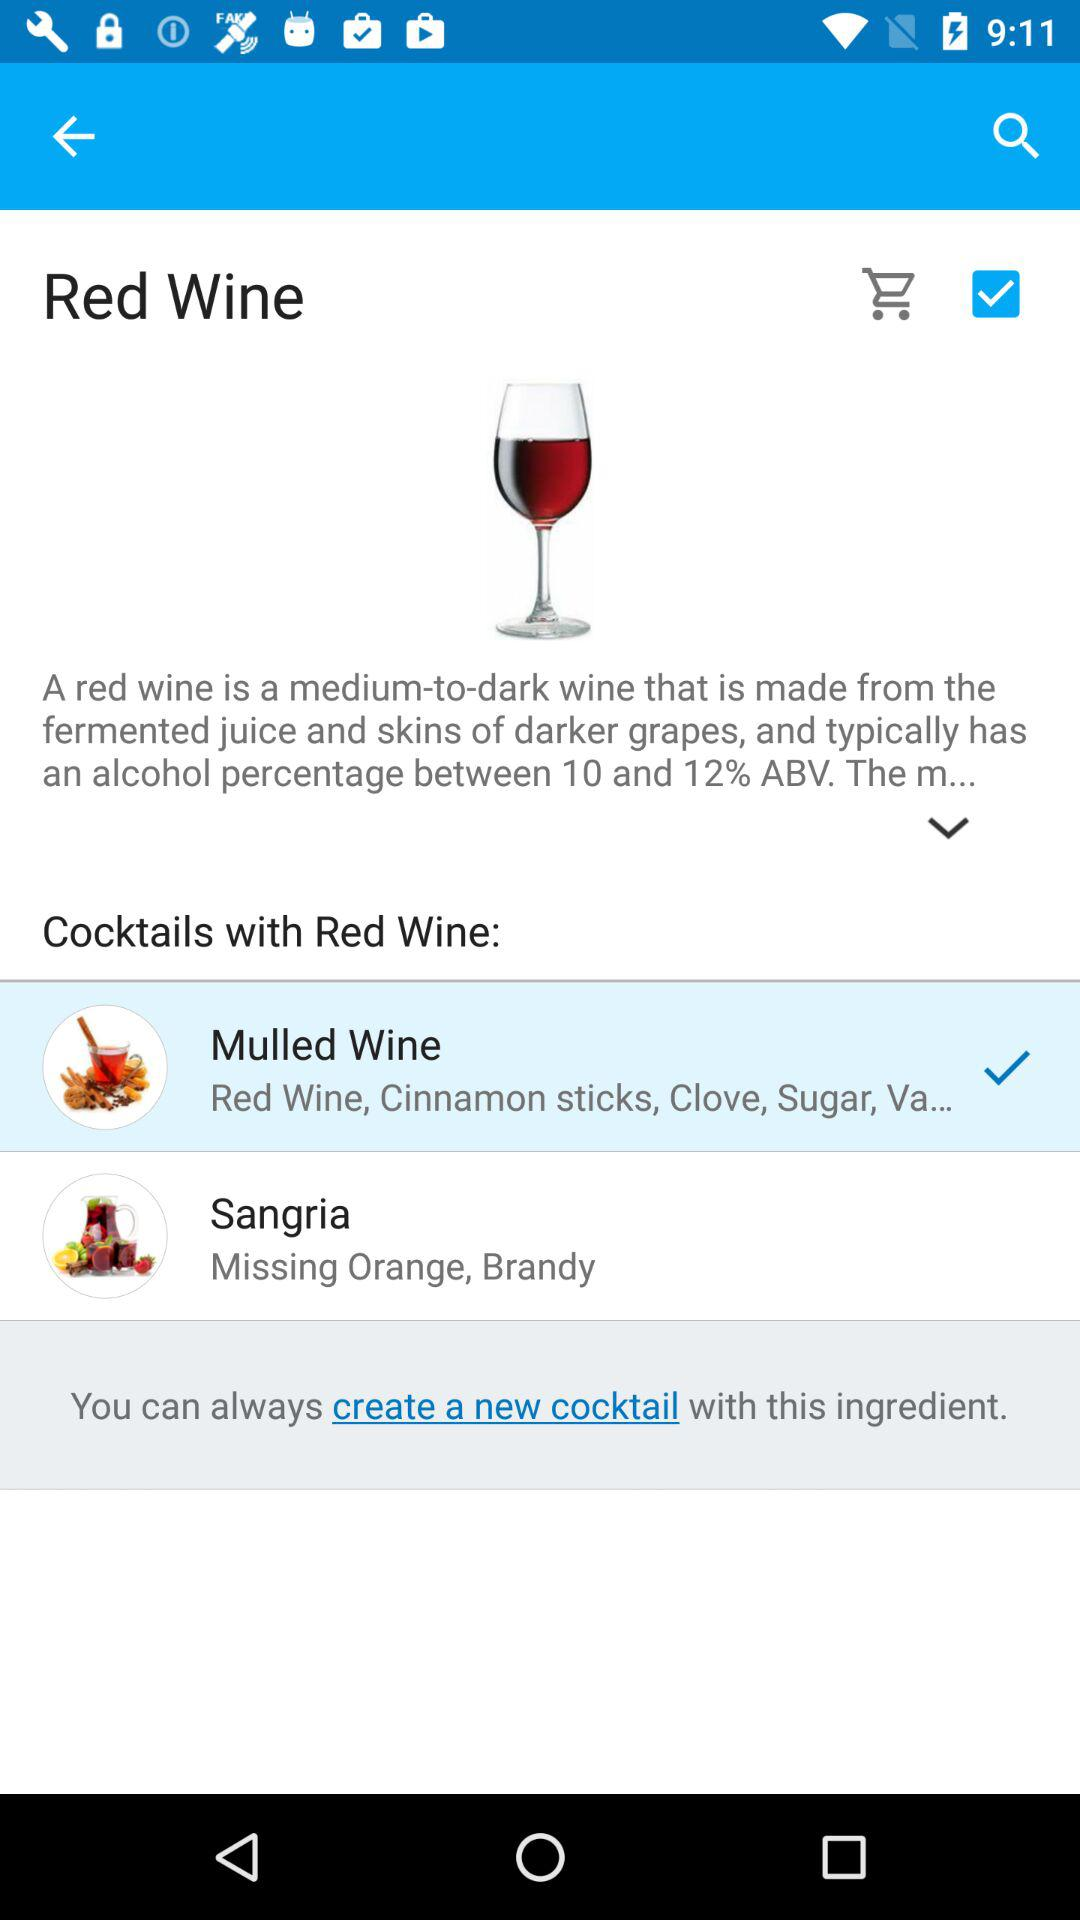How many cocktails use red wine?
Answer the question using a single word or phrase. 2 